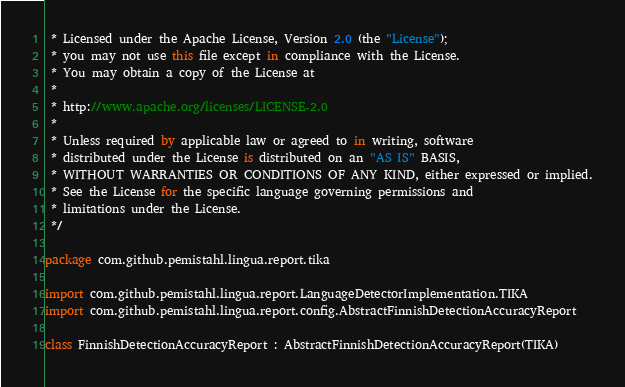Convert code to text. <code><loc_0><loc_0><loc_500><loc_500><_Kotlin_> * Licensed under the Apache License, Version 2.0 (the "License");
 * you may not use this file except in compliance with the License.
 * You may obtain a copy of the License at
 *
 * http://www.apache.org/licenses/LICENSE-2.0
 *
 * Unless required by applicable law or agreed to in writing, software
 * distributed under the License is distributed on an "AS IS" BASIS,
 * WITHOUT WARRANTIES OR CONDITIONS OF ANY KIND, either expressed or implied.
 * See the License for the specific language governing permissions and
 * limitations under the License.
 */

package com.github.pemistahl.lingua.report.tika

import com.github.pemistahl.lingua.report.LanguageDetectorImplementation.TIKA
import com.github.pemistahl.lingua.report.config.AbstractFinnishDetectionAccuracyReport

class FinnishDetectionAccuracyReport : AbstractFinnishDetectionAccuracyReport(TIKA)
</code> 